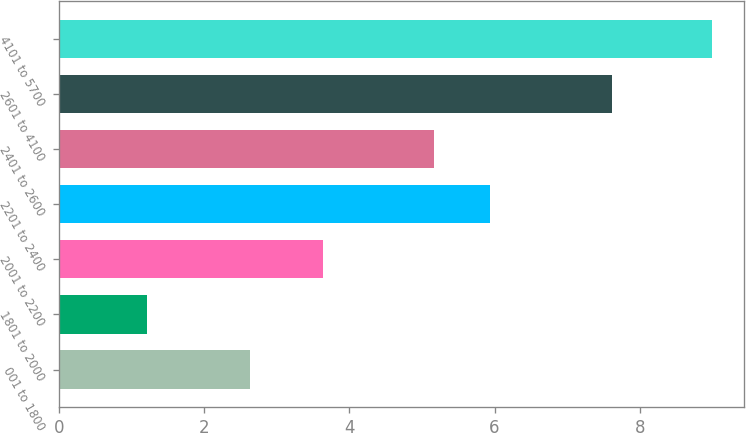<chart> <loc_0><loc_0><loc_500><loc_500><bar_chart><fcel>001 to 1800<fcel>1801 to 2000<fcel>2001 to 2200<fcel>2201 to 2400<fcel>2401 to 2600<fcel>2601 to 4100<fcel>4101 to 5700<nl><fcel>2.64<fcel>1.22<fcel>3.64<fcel>5.94<fcel>5.16<fcel>7.61<fcel>8.99<nl></chart> 